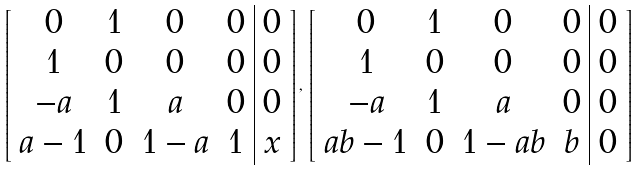Convert formula to latex. <formula><loc_0><loc_0><loc_500><loc_500>\left [ \begin{array} { c c c c | c } 0 & 1 & 0 & 0 & 0 \\ 1 & 0 & 0 & 0 & 0 \\ - a & 1 & a & 0 & 0 \\ a - 1 & 0 & 1 - a & 1 & x \end{array} \right ] , \, \left [ \begin{array} { c c c c | c } 0 & 1 & 0 & 0 & 0 \\ 1 & 0 & 0 & 0 & 0 \\ - a & 1 & a & 0 & 0 \\ a b - 1 & 0 & 1 - a b & b & 0 \end{array} \right ]</formula> 